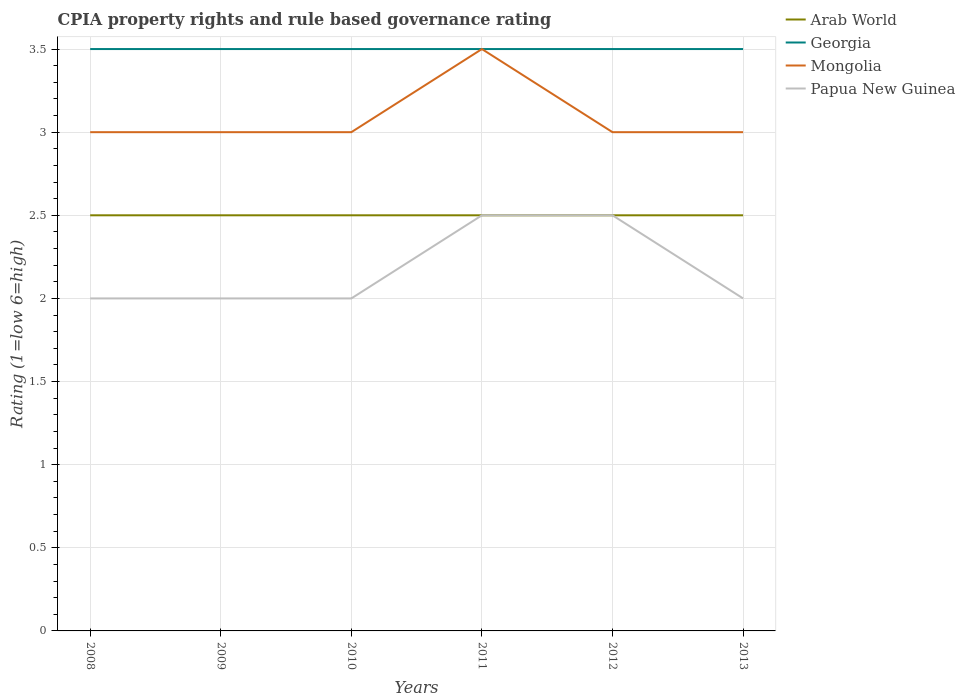How many different coloured lines are there?
Offer a very short reply. 4. Does the line corresponding to Georgia intersect with the line corresponding to Mongolia?
Your answer should be very brief. Yes. Across all years, what is the maximum CPIA rating in Georgia?
Provide a succinct answer. 3.5. In which year was the CPIA rating in Arab World maximum?
Provide a short and direct response. 2008. What is the total CPIA rating in Papua New Guinea in the graph?
Provide a short and direct response. -0.5. What is the difference between the highest and the second highest CPIA rating in Mongolia?
Offer a terse response. 0.5. Are the values on the major ticks of Y-axis written in scientific E-notation?
Offer a very short reply. No. Does the graph contain grids?
Your answer should be very brief. Yes. Where does the legend appear in the graph?
Your answer should be very brief. Top right. How many legend labels are there?
Your answer should be compact. 4. How are the legend labels stacked?
Ensure brevity in your answer.  Vertical. What is the title of the graph?
Offer a very short reply. CPIA property rights and rule based governance rating. Does "Croatia" appear as one of the legend labels in the graph?
Keep it short and to the point. No. What is the label or title of the X-axis?
Ensure brevity in your answer.  Years. What is the label or title of the Y-axis?
Your answer should be compact. Rating (1=low 6=high). What is the Rating (1=low 6=high) of Georgia in 2008?
Offer a terse response. 3.5. What is the Rating (1=low 6=high) of Mongolia in 2008?
Provide a short and direct response. 3. What is the Rating (1=low 6=high) of Papua New Guinea in 2009?
Make the answer very short. 2. What is the Rating (1=low 6=high) of Georgia in 2010?
Your answer should be very brief. 3.5. What is the Rating (1=low 6=high) in Mongolia in 2010?
Give a very brief answer. 3. What is the Rating (1=low 6=high) of Arab World in 2013?
Offer a very short reply. 2.5. What is the Rating (1=low 6=high) of Georgia in 2013?
Offer a terse response. 3.5. What is the Rating (1=low 6=high) in Mongolia in 2013?
Ensure brevity in your answer.  3. What is the Rating (1=low 6=high) in Papua New Guinea in 2013?
Ensure brevity in your answer.  2. Across all years, what is the maximum Rating (1=low 6=high) of Georgia?
Keep it short and to the point. 3.5. Across all years, what is the maximum Rating (1=low 6=high) of Mongolia?
Offer a terse response. 3.5. Across all years, what is the minimum Rating (1=low 6=high) of Arab World?
Give a very brief answer. 2.5. Across all years, what is the minimum Rating (1=low 6=high) in Georgia?
Give a very brief answer. 3.5. Across all years, what is the minimum Rating (1=low 6=high) of Papua New Guinea?
Your response must be concise. 2. What is the total Rating (1=low 6=high) of Mongolia in the graph?
Ensure brevity in your answer.  18.5. What is the difference between the Rating (1=low 6=high) of Mongolia in 2008 and that in 2010?
Your response must be concise. 0. What is the difference between the Rating (1=low 6=high) of Georgia in 2008 and that in 2011?
Provide a succinct answer. 0. What is the difference between the Rating (1=low 6=high) in Mongolia in 2008 and that in 2011?
Offer a terse response. -0.5. What is the difference between the Rating (1=low 6=high) in Papua New Guinea in 2008 and that in 2011?
Offer a very short reply. -0.5. What is the difference between the Rating (1=low 6=high) in Georgia in 2008 and that in 2012?
Give a very brief answer. 0. What is the difference between the Rating (1=low 6=high) in Mongolia in 2008 and that in 2012?
Your response must be concise. 0. What is the difference between the Rating (1=low 6=high) in Arab World in 2008 and that in 2013?
Give a very brief answer. 0. What is the difference between the Rating (1=low 6=high) of Georgia in 2008 and that in 2013?
Keep it short and to the point. 0. What is the difference between the Rating (1=low 6=high) of Mongolia in 2008 and that in 2013?
Your answer should be very brief. 0. What is the difference between the Rating (1=low 6=high) in Papua New Guinea in 2008 and that in 2013?
Your answer should be very brief. 0. What is the difference between the Rating (1=low 6=high) of Arab World in 2009 and that in 2010?
Offer a very short reply. 0. What is the difference between the Rating (1=low 6=high) in Georgia in 2009 and that in 2010?
Offer a very short reply. 0. What is the difference between the Rating (1=low 6=high) in Mongolia in 2009 and that in 2010?
Provide a short and direct response. 0. What is the difference between the Rating (1=low 6=high) of Arab World in 2009 and that in 2011?
Your answer should be very brief. 0. What is the difference between the Rating (1=low 6=high) of Mongolia in 2009 and that in 2011?
Make the answer very short. -0.5. What is the difference between the Rating (1=low 6=high) of Georgia in 2009 and that in 2012?
Keep it short and to the point. 0. What is the difference between the Rating (1=low 6=high) of Arab World in 2009 and that in 2013?
Your answer should be very brief. 0. What is the difference between the Rating (1=low 6=high) in Mongolia in 2009 and that in 2013?
Provide a succinct answer. 0. What is the difference between the Rating (1=low 6=high) in Arab World in 2010 and that in 2011?
Provide a short and direct response. 0. What is the difference between the Rating (1=low 6=high) of Mongolia in 2010 and that in 2011?
Your answer should be compact. -0.5. What is the difference between the Rating (1=low 6=high) in Papua New Guinea in 2010 and that in 2011?
Offer a terse response. -0.5. What is the difference between the Rating (1=low 6=high) in Arab World in 2010 and that in 2012?
Make the answer very short. 0. What is the difference between the Rating (1=low 6=high) of Georgia in 2010 and that in 2012?
Provide a short and direct response. 0. What is the difference between the Rating (1=low 6=high) of Georgia in 2010 and that in 2013?
Provide a succinct answer. 0. What is the difference between the Rating (1=low 6=high) of Mongolia in 2010 and that in 2013?
Your response must be concise. 0. What is the difference between the Rating (1=low 6=high) of Arab World in 2011 and that in 2012?
Keep it short and to the point. 0. What is the difference between the Rating (1=low 6=high) in Georgia in 2011 and that in 2012?
Keep it short and to the point. 0. What is the difference between the Rating (1=low 6=high) of Mongolia in 2011 and that in 2012?
Your response must be concise. 0.5. What is the difference between the Rating (1=low 6=high) in Papua New Guinea in 2011 and that in 2012?
Your response must be concise. 0. What is the difference between the Rating (1=low 6=high) of Arab World in 2008 and the Rating (1=low 6=high) of Mongolia in 2009?
Ensure brevity in your answer.  -0.5. What is the difference between the Rating (1=low 6=high) in Arab World in 2008 and the Rating (1=low 6=high) in Papua New Guinea in 2009?
Give a very brief answer. 0.5. What is the difference between the Rating (1=low 6=high) in Georgia in 2008 and the Rating (1=low 6=high) in Mongolia in 2009?
Your answer should be compact. 0.5. What is the difference between the Rating (1=low 6=high) of Georgia in 2008 and the Rating (1=low 6=high) of Papua New Guinea in 2009?
Your response must be concise. 1.5. What is the difference between the Rating (1=low 6=high) in Mongolia in 2008 and the Rating (1=low 6=high) in Papua New Guinea in 2009?
Offer a very short reply. 1. What is the difference between the Rating (1=low 6=high) of Arab World in 2008 and the Rating (1=low 6=high) of Georgia in 2010?
Provide a short and direct response. -1. What is the difference between the Rating (1=low 6=high) of Arab World in 2008 and the Rating (1=low 6=high) of Georgia in 2011?
Offer a very short reply. -1. What is the difference between the Rating (1=low 6=high) in Arab World in 2008 and the Rating (1=low 6=high) in Mongolia in 2011?
Your answer should be very brief. -1. What is the difference between the Rating (1=low 6=high) in Arab World in 2008 and the Rating (1=low 6=high) in Papua New Guinea in 2011?
Keep it short and to the point. 0. What is the difference between the Rating (1=low 6=high) of Georgia in 2008 and the Rating (1=low 6=high) of Papua New Guinea in 2011?
Provide a succinct answer. 1. What is the difference between the Rating (1=low 6=high) of Arab World in 2008 and the Rating (1=low 6=high) of Georgia in 2012?
Provide a succinct answer. -1. What is the difference between the Rating (1=low 6=high) in Arab World in 2008 and the Rating (1=low 6=high) in Papua New Guinea in 2012?
Make the answer very short. 0. What is the difference between the Rating (1=low 6=high) of Georgia in 2008 and the Rating (1=low 6=high) of Mongolia in 2012?
Your answer should be compact. 0.5. What is the difference between the Rating (1=low 6=high) in Arab World in 2008 and the Rating (1=low 6=high) in Georgia in 2013?
Your answer should be very brief. -1. What is the difference between the Rating (1=low 6=high) in Arab World in 2008 and the Rating (1=low 6=high) in Mongolia in 2013?
Ensure brevity in your answer.  -0.5. What is the difference between the Rating (1=low 6=high) of Mongolia in 2008 and the Rating (1=low 6=high) of Papua New Guinea in 2013?
Your response must be concise. 1. What is the difference between the Rating (1=low 6=high) of Arab World in 2009 and the Rating (1=low 6=high) of Mongolia in 2010?
Offer a terse response. -0.5. What is the difference between the Rating (1=low 6=high) in Georgia in 2009 and the Rating (1=low 6=high) in Mongolia in 2010?
Your response must be concise. 0.5. What is the difference between the Rating (1=low 6=high) in Mongolia in 2009 and the Rating (1=low 6=high) in Papua New Guinea in 2010?
Your answer should be very brief. 1. What is the difference between the Rating (1=low 6=high) of Arab World in 2009 and the Rating (1=low 6=high) of Mongolia in 2011?
Your answer should be compact. -1. What is the difference between the Rating (1=low 6=high) of Arab World in 2009 and the Rating (1=low 6=high) of Papua New Guinea in 2011?
Your answer should be very brief. 0. What is the difference between the Rating (1=low 6=high) of Georgia in 2009 and the Rating (1=low 6=high) of Mongolia in 2011?
Your response must be concise. 0. What is the difference between the Rating (1=low 6=high) of Georgia in 2009 and the Rating (1=low 6=high) of Papua New Guinea in 2011?
Keep it short and to the point. 1. What is the difference between the Rating (1=low 6=high) in Arab World in 2009 and the Rating (1=low 6=high) in Georgia in 2012?
Make the answer very short. -1. What is the difference between the Rating (1=low 6=high) in Arab World in 2009 and the Rating (1=low 6=high) in Mongolia in 2012?
Offer a terse response. -0.5. What is the difference between the Rating (1=low 6=high) of Georgia in 2009 and the Rating (1=low 6=high) of Mongolia in 2012?
Provide a short and direct response. 0.5. What is the difference between the Rating (1=low 6=high) in Georgia in 2009 and the Rating (1=low 6=high) in Papua New Guinea in 2012?
Offer a terse response. 1. What is the difference between the Rating (1=low 6=high) in Mongolia in 2009 and the Rating (1=low 6=high) in Papua New Guinea in 2013?
Provide a succinct answer. 1. What is the difference between the Rating (1=low 6=high) in Arab World in 2010 and the Rating (1=low 6=high) in Georgia in 2012?
Offer a terse response. -1. What is the difference between the Rating (1=low 6=high) of Arab World in 2010 and the Rating (1=low 6=high) of Mongolia in 2012?
Provide a short and direct response. -0.5. What is the difference between the Rating (1=low 6=high) of Georgia in 2010 and the Rating (1=low 6=high) of Papua New Guinea in 2012?
Offer a terse response. 1. What is the difference between the Rating (1=low 6=high) in Mongolia in 2010 and the Rating (1=low 6=high) in Papua New Guinea in 2012?
Ensure brevity in your answer.  0.5. What is the difference between the Rating (1=low 6=high) of Arab World in 2010 and the Rating (1=low 6=high) of Georgia in 2013?
Keep it short and to the point. -1. What is the difference between the Rating (1=low 6=high) in Arab World in 2010 and the Rating (1=low 6=high) in Mongolia in 2013?
Your answer should be very brief. -0.5. What is the difference between the Rating (1=low 6=high) of Arab World in 2010 and the Rating (1=low 6=high) of Papua New Guinea in 2013?
Your answer should be compact. 0.5. What is the difference between the Rating (1=low 6=high) in Georgia in 2010 and the Rating (1=low 6=high) in Mongolia in 2013?
Your answer should be very brief. 0.5. What is the difference between the Rating (1=low 6=high) of Georgia in 2010 and the Rating (1=low 6=high) of Papua New Guinea in 2013?
Offer a very short reply. 1.5. What is the difference between the Rating (1=low 6=high) of Mongolia in 2010 and the Rating (1=low 6=high) of Papua New Guinea in 2013?
Make the answer very short. 1. What is the difference between the Rating (1=low 6=high) of Arab World in 2011 and the Rating (1=low 6=high) of Papua New Guinea in 2012?
Keep it short and to the point. 0. What is the difference between the Rating (1=low 6=high) of Georgia in 2011 and the Rating (1=low 6=high) of Papua New Guinea in 2012?
Your response must be concise. 1. What is the difference between the Rating (1=low 6=high) of Mongolia in 2011 and the Rating (1=low 6=high) of Papua New Guinea in 2012?
Offer a terse response. 1. What is the difference between the Rating (1=low 6=high) of Arab World in 2011 and the Rating (1=low 6=high) of Mongolia in 2013?
Provide a short and direct response. -0.5. What is the difference between the Rating (1=low 6=high) in Arab World in 2011 and the Rating (1=low 6=high) in Papua New Guinea in 2013?
Your answer should be compact. 0.5. What is the difference between the Rating (1=low 6=high) of Arab World in 2012 and the Rating (1=low 6=high) of Georgia in 2013?
Offer a terse response. -1. What is the difference between the Rating (1=low 6=high) in Arab World in 2012 and the Rating (1=low 6=high) in Mongolia in 2013?
Ensure brevity in your answer.  -0.5. What is the difference between the Rating (1=low 6=high) of Arab World in 2012 and the Rating (1=low 6=high) of Papua New Guinea in 2013?
Provide a short and direct response. 0.5. What is the difference between the Rating (1=low 6=high) in Georgia in 2012 and the Rating (1=low 6=high) in Mongolia in 2013?
Make the answer very short. 0.5. What is the average Rating (1=low 6=high) in Mongolia per year?
Offer a very short reply. 3.08. What is the average Rating (1=low 6=high) in Papua New Guinea per year?
Offer a very short reply. 2.17. In the year 2008, what is the difference between the Rating (1=low 6=high) in Arab World and Rating (1=low 6=high) in Mongolia?
Keep it short and to the point. -0.5. In the year 2008, what is the difference between the Rating (1=low 6=high) in Georgia and Rating (1=low 6=high) in Mongolia?
Your answer should be compact. 0.5. In the year 2008, what is the difference between the Rating (1=low 6=high) of Mongolia and Rating (1=low 6=high) of Papua New Guinea?
Ensure brevity in your answer.  1. In the year 2009, what is the difference between the Rating (1=low 6=high) of Arab World and Rating (1=low 6=high) of Georgia?
Offer a terse response. -1. In the year 2009, what is the difference between the Rating (1=low 6=high) in Georgia and Rating (1=low 6=high) in Papua New Guinea?
Your answer should be very brief. 1.5. In the year 2009, what is the difference between the Rating (1=low 6=high) in Mongolia and Rating (1=low 6=high) in Papua New Guinea?
Make the answer very short. 1. In the year 2010, what is the difference between the Rating (1=low 6=high) of Georgia and Rating (1=low 6=high) of Mongolia?
Your answer should be very brief. 0.5. In the year 2010, what is the difference between the Rating (1=low 6=high) of Mongolia and Rating (1=low 6=high) of Papua New Guinea?
Your answer should be compact. 1. In the year 2011, what is the difference between the Rating (1=low 6=high) of Arab World and Rating (1=low 6=high) of Mongolia?
Your response must be concise. -1. In the year 2011, what is the difference between the Rating (1=low 6=high) in Georgia and Rating (1=low 6=high) in Papua New Guinea?
Offer a terse response. 1. In the year 2012, what is the difference between the Rating (1=low 6=high) of Georgia and Rating (1=low 6=high) of Papua New Guinea?
Make the answer very short. 1. In the year 2013, what is the difference between the Rating (1=low 6=high) of Arab World and Rating (1=low 6=high) of Georgia?
Your answer should be very brief. -1. In the year 2013, what is the difference between the Rating (1=low 6=high) in Arab World and Rating (1=low 6=high) in Mongolia?
Your answer should be compact. -0.5. In the year 2013, what is the difference between the Rating (1=low 6=high) in Arab World and Rating (1=low 6=high) in Papua New Guinea?
Provide a short and direct response. 0.5. In the year 2013, what is the difference between the Rating (1=low 6=high) in Georgia and Rating (1=low 6=high) in Mongolia?
Keep it short and to the point. 0.5. What is the ratio of the Rating (1=low 6=high) in Mongolia in 2008 to that in 2009?
Offer a very short reply. 1. What is the ratio of the Rating (1=low 6=high) of Georgia in 2008 to that in 2010?
Offer a very short reply. 1. What is the ratio of the Rating (1=low 6=high) of Papua New Guinea in 2008 to that in 2010?
Your answer should be compact. 1. What is the ratio of the Rating (1=low 6=high) in Arab World in 2008 to that in 2011?
Your answer should be compact. 1. What is the ratio of the Rating (1=low 6=high) in Georgia in 2008 to that in 2011?
Provide a succinct answer. 1. What is the ratio of the Rating (1=low 6=high) of Mongolia in 2008 to that in 2011?
Your answer should be very brief. 0.86. What is the ratio of the Rating (1=low 6=high) of Arab World in 2008 to that in 2012?
Offer a very short reply. 1. What is the ratio of the Rating (1=low 6=high) in Georgia in 2008 to that in 2013?
Keep it short and to the point. 1. What is the ratio of the Rating (1=low 6=high) of Mongolia in 2008 to that in 2013?
Provide a short and direct response. 1. What is the ratio of the Rating (1=low 6=high) in Papua New Guinea in 2008 to that in 2013?
Keep it short and to the point. 1. What is the ratio of the Rating (1=low 6=high) in Georgia in 2009 to that in 2010?
Give a very brief answer. 1. What is the ratio of the Rating (1=low 6=high) in Mongolia in 2009 to that in 2010?
Offer a very short reply. 1. What is the ratio of the Rating (1=low 6=high) of Papua New Guinea in 2009 to that in 2010?
Ensure brevity in your answer.  1. What is the ratio of the Rating (1=low 6=high) in Georgia in 2009 to that in 2011?
Provide a succinct answer. 1. What is the ratio of the Rating (1=low 6=high) in Mongolia in 2009 to that in 2011?
Provide a succinct answer. 0.86. What is the ratio of the Rating (1=low 6=high) in Arab World in 2009 to that in 2012?
Provide a succinct answer. 1. What is the ratio of the Rating (1=low 6=high) in Georgia in 2009 to that in 2012?
Offer a terse response. 1. What is the ratio of the Rating (1=low 6=high) in Mongolia in 2009 to that in 2012?
Offer a very short reply. 1. What is the ratio of the Rating (1=low 6=high) of Georgia in 2009 to that in 2013?
Provide a succinct answer. 1. What is the ratio of the Rating (1=low 6=high) in Mongolia in 2009 to that in 2013?
Your answer should be compact. 1. What is the ratio of the Rating (1=low 6=high) in Arab World in 2010 to that in 2011?
Give a very brief answer. 1. What is the ratio of the Rating (1=low 6=high) in Georgia in 2010 to that in 2011?
Ensure brevity in your answer.  1. What is the ratio of the Rating (1=low 6=high) in Mongolia in 2010 to that in 2011?
Provide a short and direct response. 0.86. What is the ratio of the Rating (1=low 6=high) of Arab World in 2010 to that in 2012?
Offer a very short reply. 1. What is the ratio of the Rating (1=low 6=high) of Georgia in 2010 to that in 2012?
Keep it short and to the point. 1. What is the ratio of the Rating (1=low 6=high) in Papua New Guinea in 2010 to that in 2012?
Your answer should be very brief. 0.8. What is the ratio of the Rating (1=low 6=high) of Arab World in 2010 to that in 2013?
Provide a succinct answer. 1. What is the ratio of the Rating (1=low 6=high) of Georgia in 2010 to that in 2013?
Provide a short and direct response. 1. What is the ratio of the Rating (1=low 6=high) of Georgia in 2011 to that in 2012?
Provide a succinct answer. 1. What is the ratio of the Rating (1=low 6=high) in Mongolia in 2011 to that in 2012?
Your answer should be very brief. 1.17. What is the ratio of the Rating (1=low 6=high) of Papua New Guinea in 2011 to that in 2012?
Make the answer very short. 1. What is the ratio of the Rating (1=low 6=high) of Georgia in 2011 to that in 2013?
Your response must be concise. 1. What is the ratio of the Rating (1=low 6=high) in Papua New Guinea in 2011 to that in 2013?
Keep it short and to the point. 1.25. What is the ratio of the Rating (1=low 6=high) in Arab World in 2012 to that in 2013?
Give a very brief answer. 1. What is the ratio of the Rating (1=low 6=high) in Georgia in 2012 to that in 2013?
Ensure brevity in your answer.  1. What is the difference between the highest and the second highest Rating (1=low 6=high) of Arab World?
Offer a very short reply. 0. What is the difference between the highest and the second highest Rating (1=low 6=high) in Mongolia?
Offer a terse response. 0.5. 